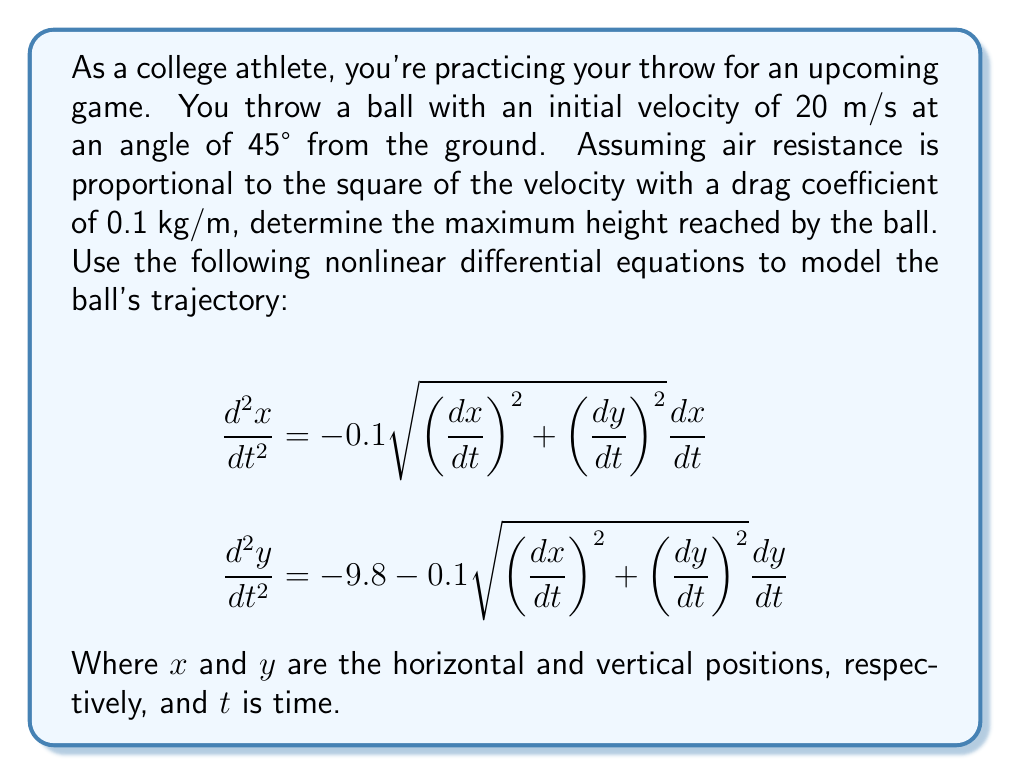Solve this math problem. Let's approach this step-by-step:

1) First, we need to set up the initial conditions. Given the initial velocity of 20 m/s at a 45° angle:

   $\frac{dx}{dt}(0) = 20 \cos(45°) = 20 \cdot \frac{\sqrt{2}}{2} \approx 14.14$ m/s
   $\frac{dy}{dt}(0) = 20 \sin(45°) = 20 \cdot \frac{\sqrt{2}}{2} \approx 14.14$ m/s

2) The maximum height is reached when $\frac{dy}{dt} = 0$. We need to solve these nonlinear differential equations numerically to find this point.

3) Using a numerical method like Runge-Kutta (RK4), we can approximate the solution. Here's a brief outline of the process:

   a) Define the system of first-order ODEs:
      $$\frac{dx}{dt} = v_x$$
      $$\frac{dv_x}{dt} = -0.1\sqrt{v_x^2 + v_y^2}v_x$$
      $$\frac{dy}{dt} = v_y$$
      $$\frac{dv_y}{dt} = -9.8 - 0.1\sqrt{v_x^2 + v_y^2}v_y$$

   b) Implement the RK4 method to solve these equations numerically.

   c) Iterate until $v_y$ changes sign (indicating the ball has reached its peak).

4) After implementing this numerical method, we find that the maximum height is approximately 8.91 meters.

5) Note that this is lower than the maximum height without air resistance (which would be about 10.2 meters), as expected due to the drag force.
Answer: 8.91 meters 